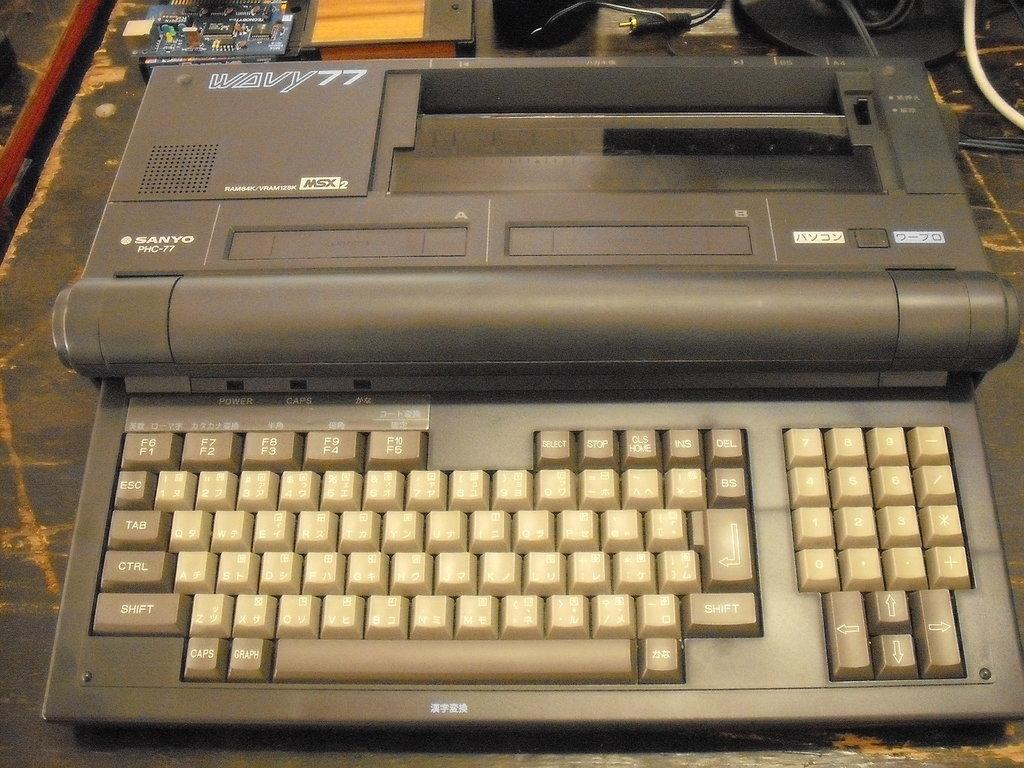<image>
Describe the image concisely. A tan colored Sanyo PHS-77 electric type writer. 